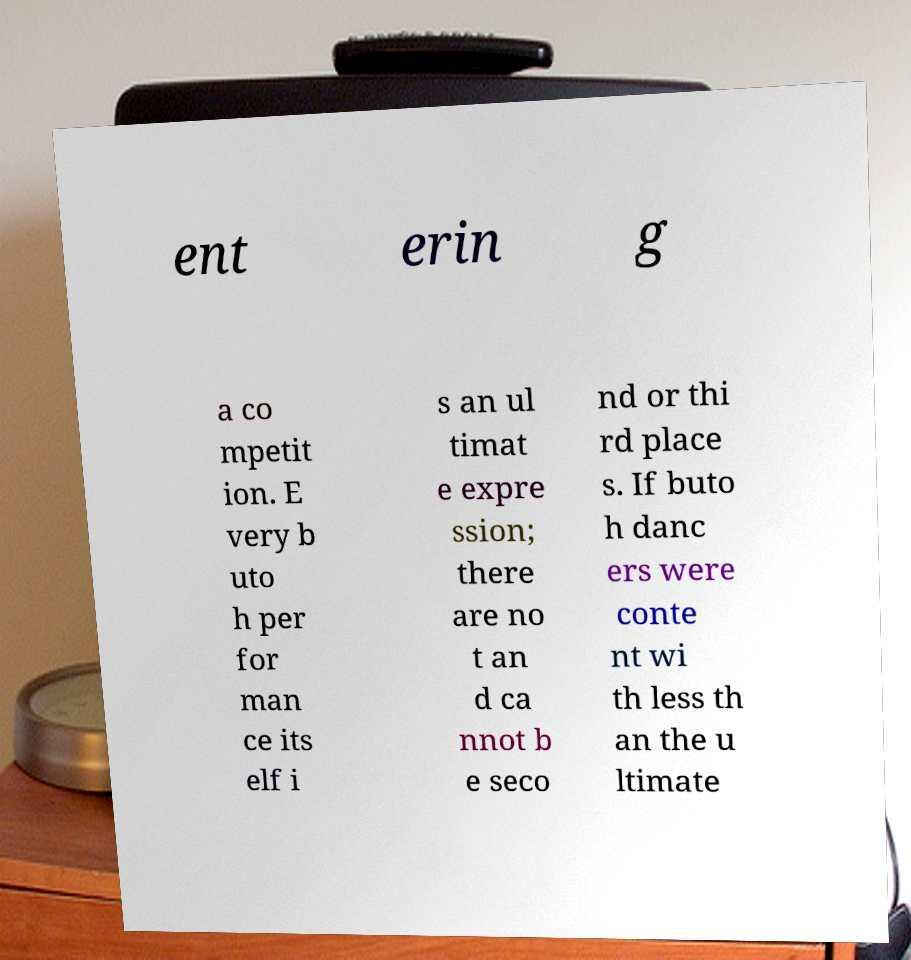Can you read and provide the text displayed in the image?This photo seems to have some interesting text. Can you extract and type it out for me? ent erin g a co mpetit ion. E very b uto h per for man ce its elf i s an ul timat e expre ssion; there are no t an d ca nnot b e seco nd or thi rd place s. If buto h danc ers were conte nt wi th less th an the u ltimate 